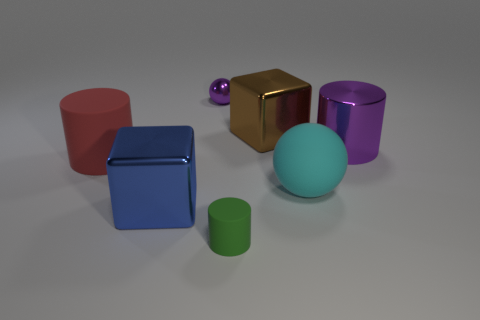What is the size of the thing that is in front of the large blue metallic block?
Your response must be concise. Small. Does the ball left of the small green rubber object have the same color as the large cylinder that is to the right of the big ball?
Offer a terse response. Yes. How many other things are there of the same shape as the cyan thing?
Ensure brevity in your answer.  1. Are there the same number of big cyan rubber objects in front of the blue cube and purple objects to the left of the big rubber ball?
Provide a short and direct response. No. Is the large block in front of the big red rubber thing made of the same material as the big block behind the large red object?
Your response must be concise. Yes. What number of other objects are the same size as the red rubber cylinder?
Your response must be concise. 4. How many objects are either large brown objects or things on the left side of the large brown object?
Give a very brief answer. 5. Are there the same number of cyan spheres behind the matte sphere and gray rubber blocks?
Give a very brief answer. Yes. The large cyan thing that is the same material as the red cylinder is what shape?
Keep it short and to the point. Sphere. Are there any metal cylinders that have the same color as the tiny ball?
Your response must be concise. Yes. 